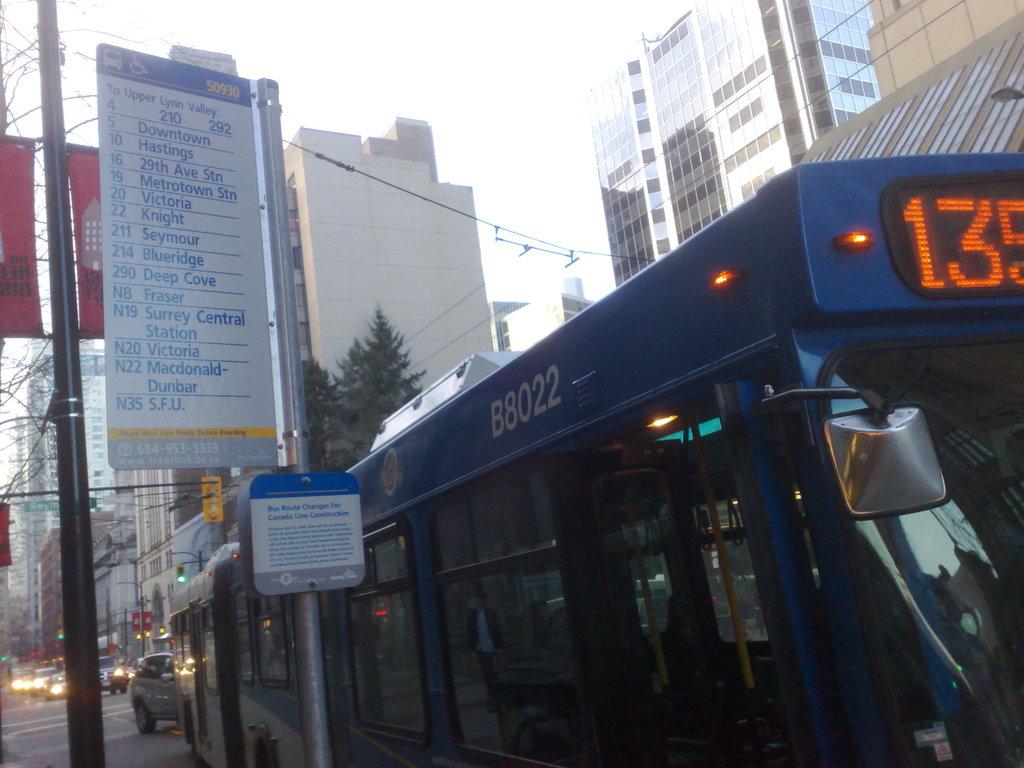What number is shown on the bus?
Provide a short and direct response. 135. What does the sign say that is blue at the top an beside the bus?
Your response must be concise. Unanswerable. 